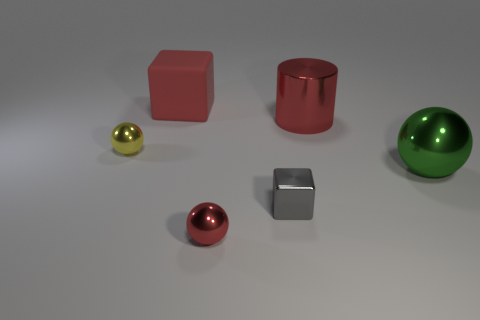There is a big object that is the same shape as the small gray object; what material is it?
Your answer should be very brief. Rubber. There is a red metallic object that is in front of the big green ball; is it the same shape as the large green shiny thing?
Make the answer very short. Yes. How many yellow metallic things have the same shape as the tiny red shiny thing?
Your response must be concise. 1. There is a big rubber thing; does it have the same color as the large shiny object that is behind the big sphere?
Your answer should be compact. Yes. Is there a matte cube of the same color as the large cylinder?
Provide a short and direct response. Yes. What is the material of the large cube that is the same color as the big cylinder?
Offer a very short reply. Rubber. What number of red things are either blocks or small metallic blocks?
Offer a very short reply. 1. There is a cylinder that is the same color as the large rubber cube; what is its size?
Provide a short and direct response. Large. Is the number of big green metal balls greater than the number of big rubber cylinders?
Provide a succinct answer. Yes. Do the large cylinder and the big rubber cube have the same color?
Make the answer very short. Yes. 